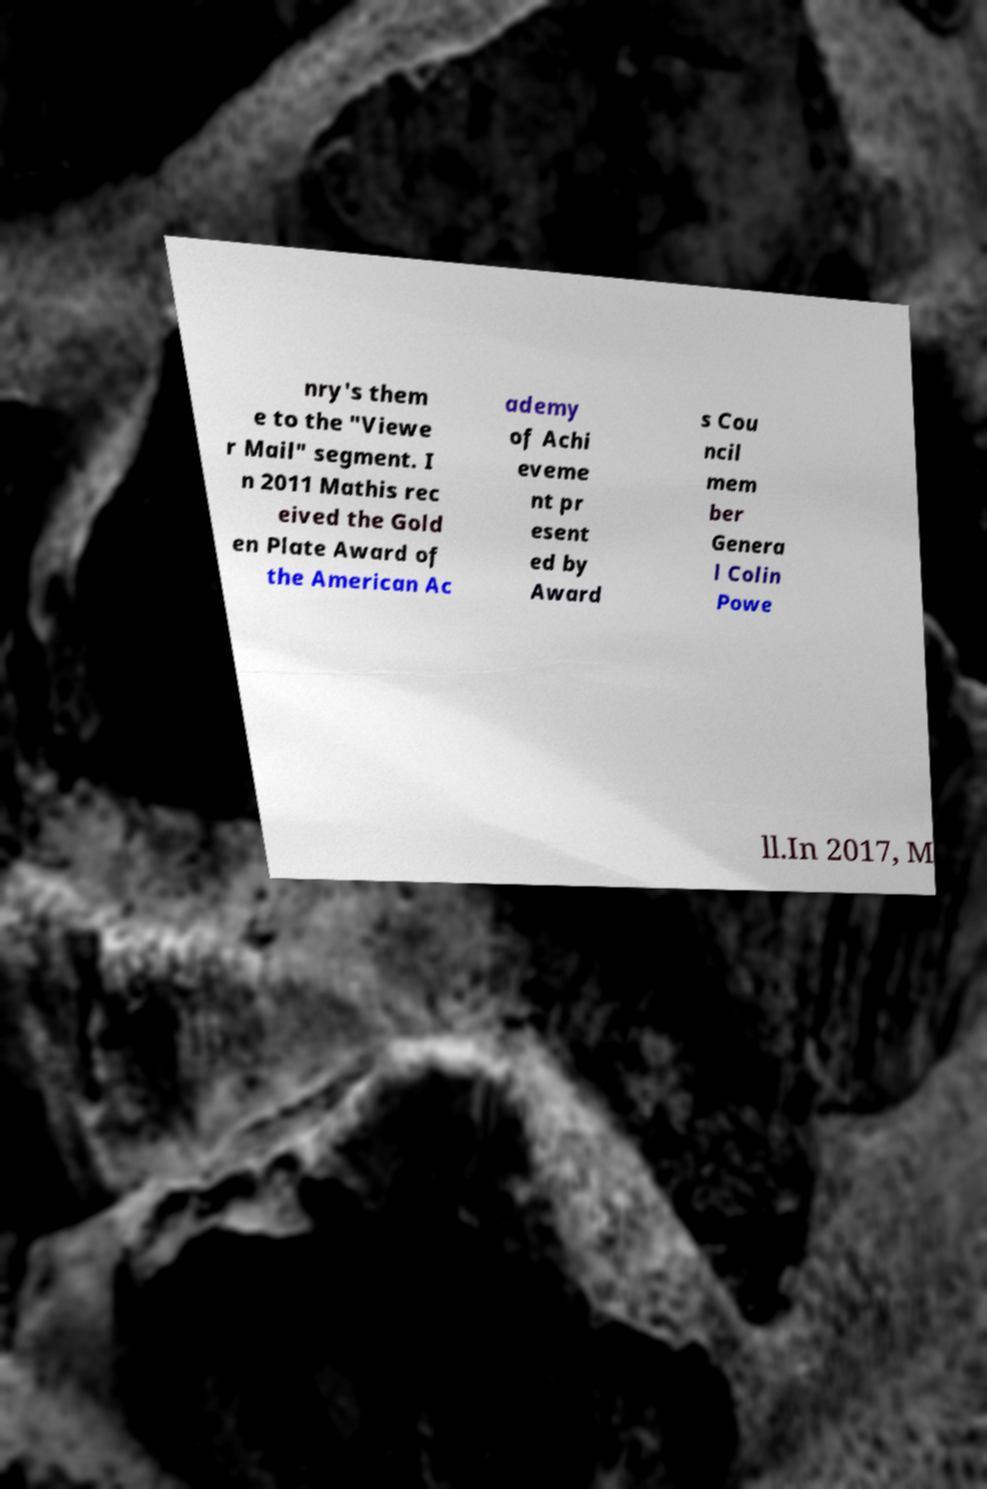There's text embedded in this image that I need extracted. Can you transcribe it verbatim? nry's them e to the "Viewe r Mail" segment. I n 2011 Mathis rec eived the Gold en Plate Award of the American Ac ademy of Achi eveme nt pr esent ed by Award s Cou ncil mem ber Genera l Colin Powe ll.In 2017, M 